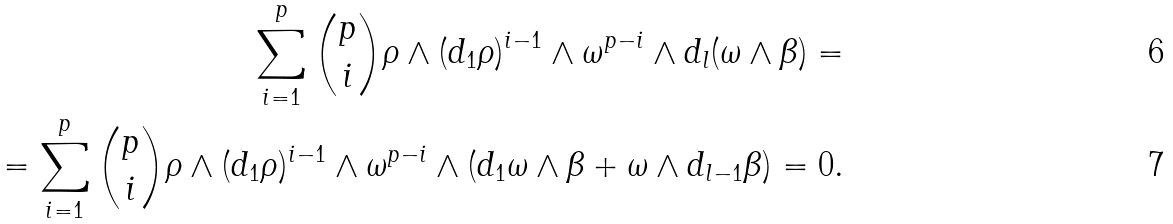Convert formula to latex. <formula><loc_0><loc_0><loc_500><loc_500>\sum _ { i = 1 } ^ { p } \binom { p } { i } \rho \wedge ( d _ { 1 } \rho ) ^ { i - 1 } \wedge \omega ^ { p - i } \wedge d _ { l } ( \omega \wedge \beta ) = \\ = \sum _ { i = 1 } ^ { p } \binom { p } { i } \rho \wedge ( d _ { 1 } \rho ) ^ { i - 1 } \wedge \omega ^ { p - i } \wedge ( d _ { 1 } \omega \wedge \beta + \omega \wedge d _ { l - 1 } \beta ) = 0 .</formula> 